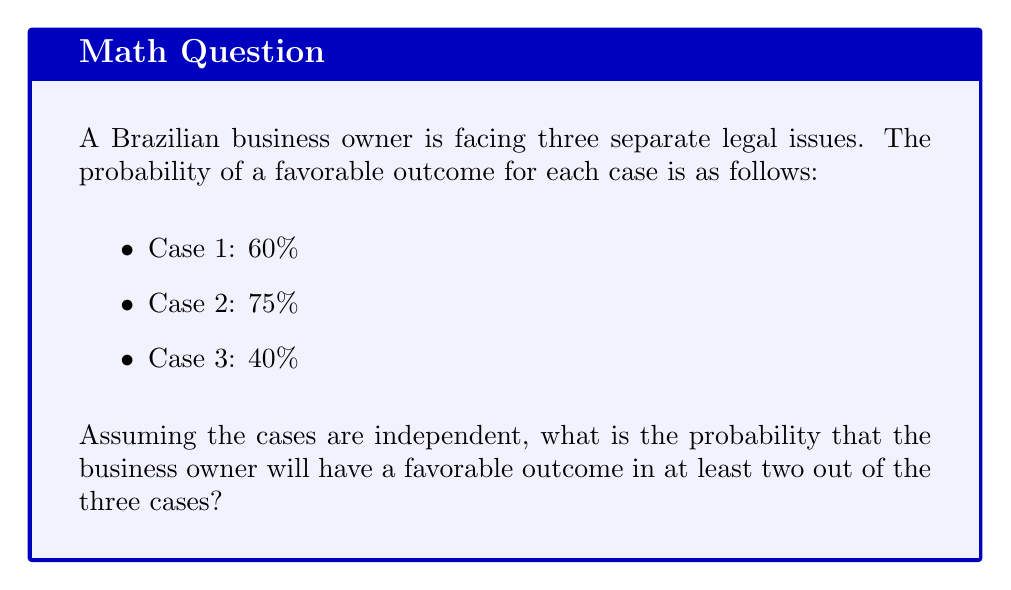Give your solution to this math problem. To solve this problem, we need to use the concept of probability for multiple independent events. Let's approach this step-by-step:

1) First, let's define our events:
   A: favorable outcome in Case 1 (P(A) = 0.60)
   B: favorable outcome in Case 2 (P(B) = 0.75)
   C: favorable outcome in Case 3 (P(C) = 0.40)

2) We need to find the probability of having at least two favorable outcomes. This can happen in four ways:
   - All three cases have favorable outcomes
   - Cases 1 and 2 have favorable outcomes, but 3 doesn't
   - Cases 1 and 3 have favorable outcomes, but 2 doesn't
   - Cases 2 and 3 have favorable outcomes, but 1 doesn't

3) Let's calculate each of these probabilities:

   P(All favorable) = P(A) × P(B) × P(C)
                    = 0.60 × 0.75 × 0.40 = 0.18

   P(1 and 2, not 3) = P(A) × P(B) × (1 - P(C))
                     = 0.60 × 0.75 × 0.60 = 0.27

   P(1 and 3, not 2) = P(A) × (1 - P(B)) × P(C)
                     = 0.60 × 0.25 × 0.40 = 0.06

   P(2 and 3, not 1) = (1 - P(A)) × P(B) × P(C)
                     = 0.40 × 0.75 × 0.40 = 0.12

4) The total probability is the sum of these individual probabilities:

   P(at least two favorable) = 0.18 + 0.27 + 0.06 + 0.12 = 0.63

Therefore, the probability of having a favorable outcome in at least two out of the three cases is 0.63 or 63%.
Answer: The probability of a favorable outcome in at least two out of the three cases is 0.63 or 63%. 